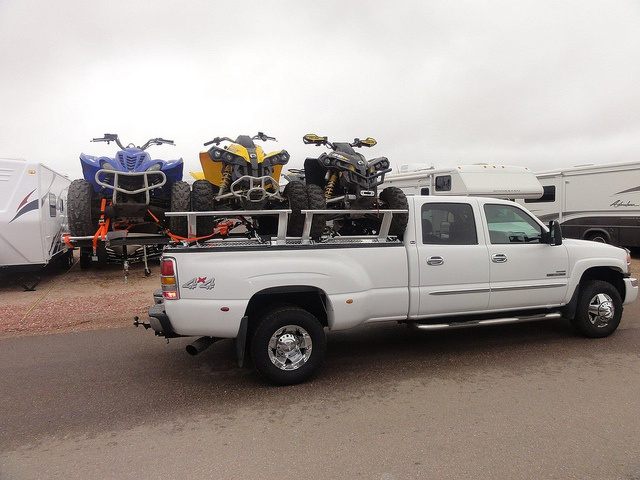Describe the objects in this image and their specific colors. I can see truck in lightgray, black, darkgray, and gray tones, car in lightgray, darkgray, black, and gray tones, bus in lightgray, darkgray, black, and gray tones, motorcycle in lightgray, black, gray, olive, and darkgray tones, and motorcycle in lightgray, black, gray, and darkgray tones in this image. 